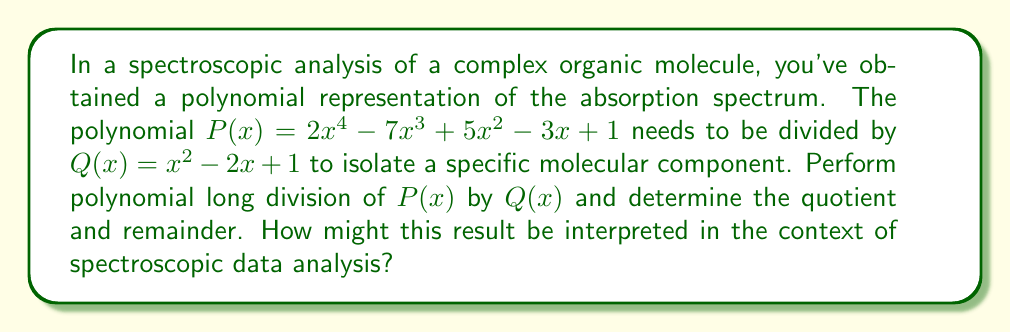Can you answer this question? Let's perform the polynomial long division step by step:

1) Set up the division:
   $$\frac{2x^4 - 7x^3 + 5x^2 - 3x + 1}{x^2 - 2x + 1}$$

2) Divide $2x^4$ by $x^2$:
   $2x^2$ goes into the quotient
   Multiply $(2x^2)(x^2 - 2x + 1) = 2x^4 - 4x^3 + 2x^2$
   Subtract: $2x^4 - 7x^3 + 5x^2 - 3x + 1 - (2x^4 - 4x^3 + 2x^2) = -3x^3 + 3x^2 - 3x + 1$

3) Bring down the rest of the polynomial and continue division:
   Divide $-3x^3$ by $x^2$:
   $-3x$ goes into the quotient
   Multiply $(-3x)(x^2 - 2x + 1) = -3x^3 + 6x^2 - 3x$
   Subtract: $-3x^3 + 3x^2 - 3x + 1 - (-3x^3 + 6x^2 - 3x) = -3x^2 + 1$

4) Continue division:
   Divide $-3x^2$ by $x^2$:
   $-3$ goes into the quotient
   Multiply $(-3)(x^2 - 2x + 1) = -3x^2 + 6x - 3$
   Subtract: $-3x^2 + 1 - (-3x^2 + 6x - 3) = -6x + 4$

5) The process ends here as the degree of $-6x + 4$ is less than the degree of $x^2 - 2x + 1$

Therefore, the quotient is $2x^2 - 3x - 3$ and the remainder is $-6x + 4$.

Interpretation: In spectroscopic data analysis, the quotient $2x^2 - 3x - 3$ could represent the main absorption peaks of the isolated molecular component, while the remainder $-6x + 4$ might indicate residual absorption or noise in the spectrum. This division process effectively separates the spectral signature of interest from background or interfering signals.
Answer: Quotient: $2x^2 - 3x - 3$, Remainder: $-6x + 4$ 